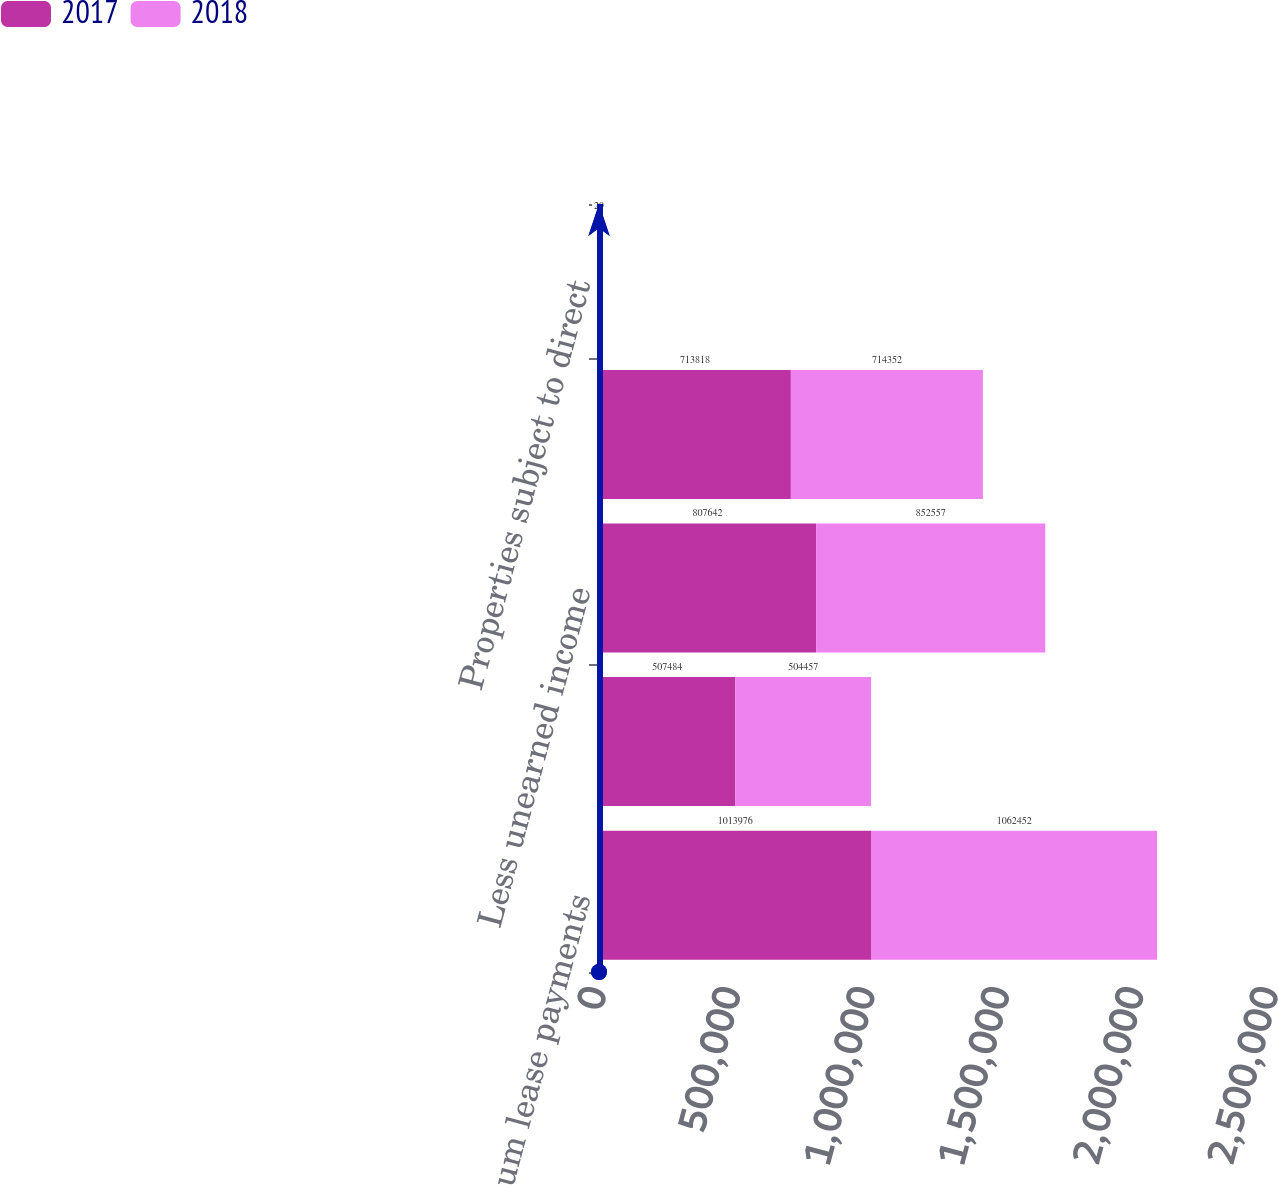Convert chart to OTSL. <chart><loc_0><loc_0><loc_500><loc_500><stacked_bar_chart><ecel><fcel>Minimum lease payments<fcel>Estimated residual value<fcel>Less unearned income<fcel>Net investment in direct<fcel>Properties subject to direct<nl><fcel>2017<fcel>1.01398e+06<fcel>507484<fcel>807642<fcel>713818<fcel>29<nl><fcel>2018<fcel>1.06245e+06<fcel>504457<fcel>852557<fcel>714352<fcel>29<nl></chart> 